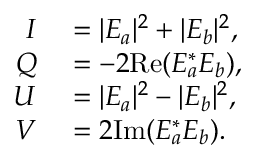Convert formula to latex. <formula><loc_0><loc_0><loc_500><loc_500>\begin{array} { r l } { I } & = | E _ { a } | ^ { 2 } + | E _ { b } | ^ { 2 } , } \\ { Q } & = - 2 R e ( E _ { a } ^ { * } E _ { b } ) , } \\ { U } & = | E _ { a } | ^ { 2 } - | E _ { b } | ^ { 2 } , } \\ { V } & = 2 I m ( E _ { a } ^ { * } E _ { b } ) . } \end{array}</formula> 